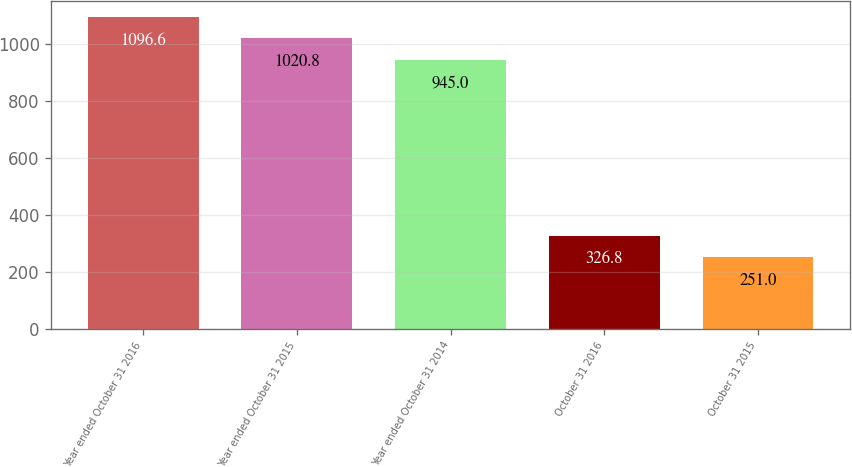Convert chart. <chart><loc_0><loc_0><loc_500><loc_500><bar_chart><fcel>Year ended October 31 2016<fcel>Year ended October 31 2015<fcel>Year ended October 31 2014<fcel>October 31 2016<fcel>October 31 2015<nl><fcel>1096.6<fcel>1020.8<fcel>945<fcel>326.8<fcel>251<nl></chart> 